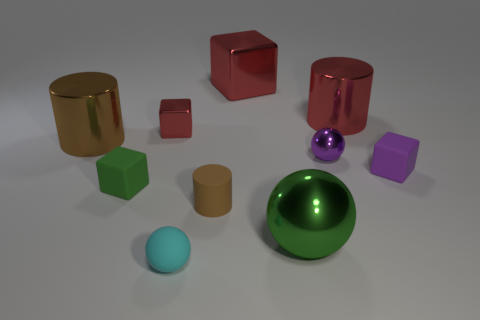Subtract all small balls. How many balls are left? 1 Subtract all purple blocks. How many blocks are left? 3 Subtract all cylinders. How many objects are left? 7 Add 6 green balls. How many green balls are left? 7 Add 4 purple cylinders. How many purple cylinders exist? 4 Subtract 0 cyan blocks. How many objects are left? 10 Subtract 1 balls. How many balls are left? 2 Subtract all blue blocks. Subtract all red spheres. How many blocks are left? 4 Subtract all red blocks. How many brown spheres are left? 0 Subtract all green shiny objects. Subtract all matte blocks. How many objects are left? 7 